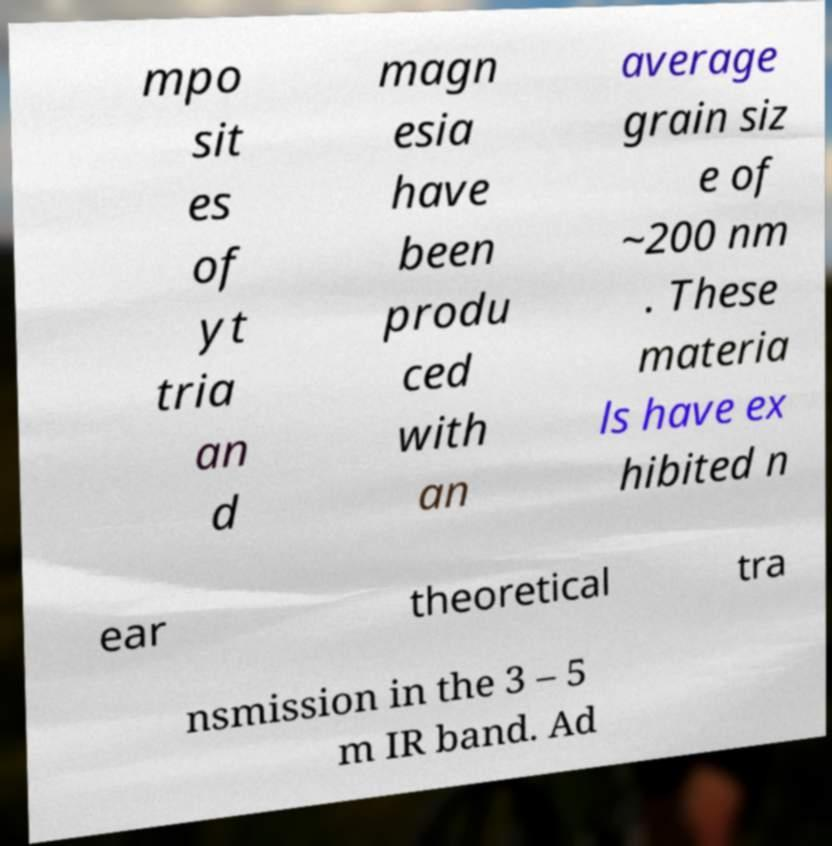Can you accurately transcribe the text from the provided image for me? mpo sit es of yt tria an d magn esia have been produ ced with an average grain siz e of ~200 nm . These materia ls have ex hibited n ear theoretical tra nsmission in the 3 – 5 m IR band. Ad 